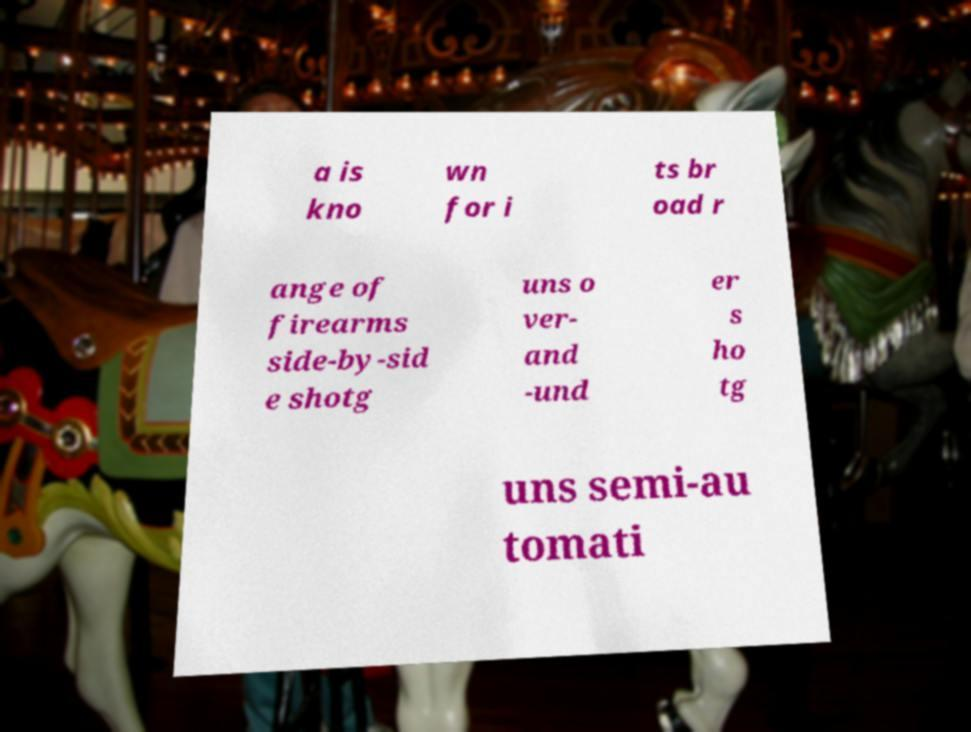Could you assist in decoding the text presented in this image and type it out clearly? a is kno wn for i ts br oad r ange of firearms side-by-sid e shotg uns o ver- and -und er s ho tg uns semi-au tomati 